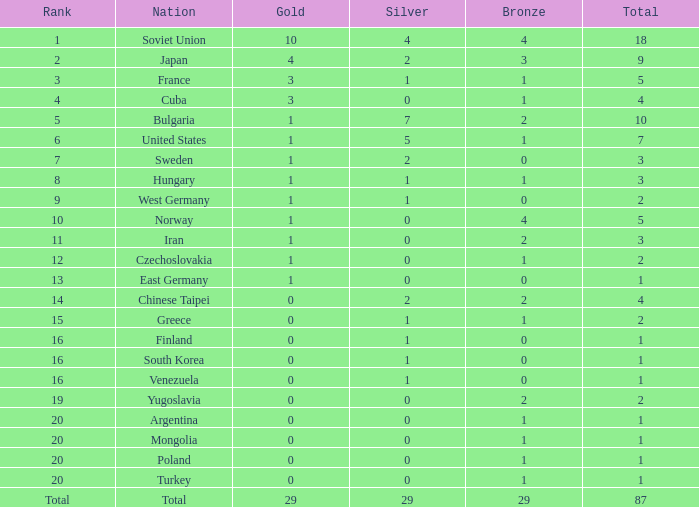What is the mean number of bronze medals across all countries? 29.0. 